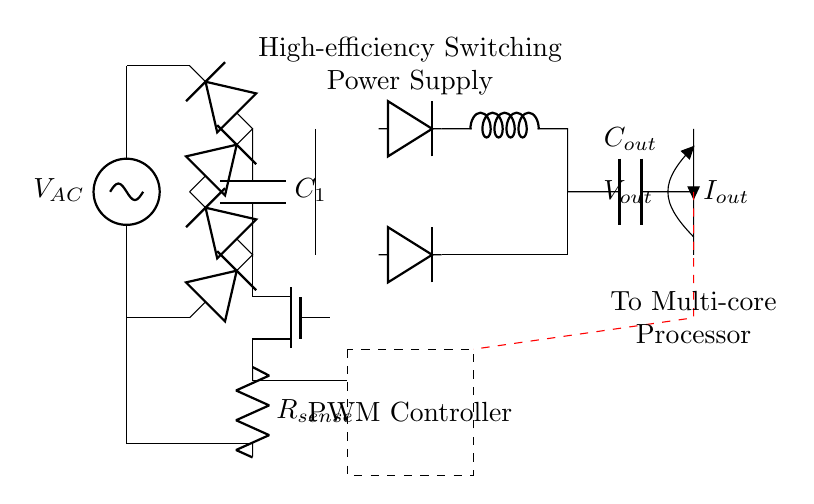What is the input voltage for the circuit? The input voltage is represented by the symbol V subscript AC, which indicates the alternating current voltage source connected at the circuit's input.
Answer: V subscript AC What does the capacitor C subscript one do in the circuit? Capacitor C subscript one is placed after the bridge rectifier and functions to smooth out the rectified voltage, reducing ripple and providing a more stable DC output.
Answer: Smooth DC output Which component is responsible for switching in the circuit? The component responsible for switching is the MOSFET, indicated in the circuit. Its function is to rapidly switch the power supply to the load based on the control signals from the PWM controller.
Answer: MOSFET What is the role of the PWM controller? The PWM controller's role is to regulate the output voltage by controlling the duty cycle of the signals sent to the MOSFET, thereby managing the power delivered to the load connected to the circuit.
Answer: Regulate output voltage What does the inductor L do in the output section? The inductor L, located in the output section of the circuit, works to filter the output current by smoothing out the fluctuations, which helps to deliver a more stable output current to the multi-core processor.
Answer: Filter output current What type of rectifier is used in the circuit? The circuit employs a bridge rectifier configuration, which consists of four diodes arranged to convert AC voltage into DC voltage by allowing both halves of the AC waveform to be utilized.
Answer: Bridge rectifier How does the feedback mechanism work in this power supply circuit? The feedback mechanism involves a signal path that connects the output back to the PWM controller, allowing for continuous monitoring and adjustment of the output voltage, which ensures consistent performance under varying load conditions.
Answer: Continuous monitoring 